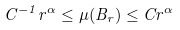<formula> <loc_0><loc_0><loc_500><loc_500>C ^ { - 1 } r ^ { \alpha } \leq \mu ( B _ { r } ) \leq C r ^ { \alpha }</formula> 